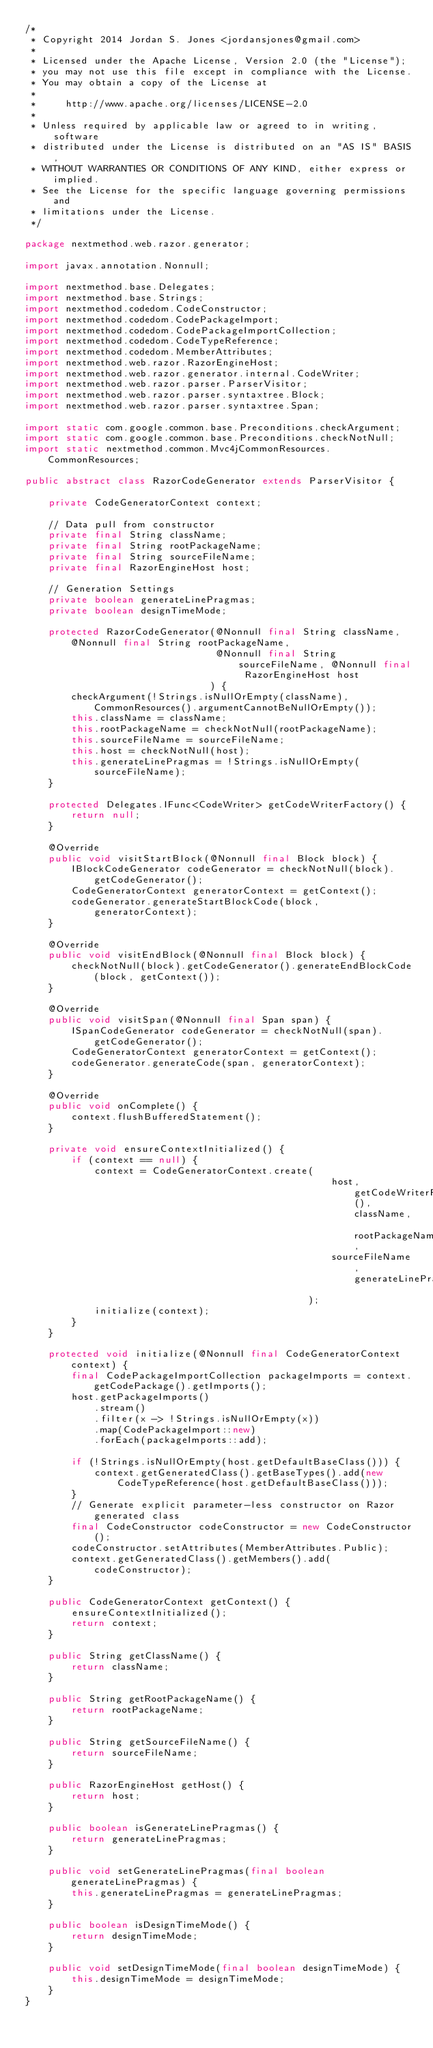<code> <loc_0><loc_0><loc_500><loc_500><_Java_>/*
 * Copyright 2014 Jordan S. Jones <jordansjones@gmail.com>
 *
 * Licensed under the Apache License, Version 2.0 (the "License");
 * you may not use this file except in compliance with the License.
 * You may obtain a copy of the License at
 *
 *     http://www.apache.org/licenses/LICENSE-2.0
 *
 * Unless required by applicable law or agreed to in writing, software
 * distributed under the License is distributed on an "AS IS" BASIS,
 * WITHOUT WARRANTIES OR CONDITIONS OF ANY KIND, either express or implied.
 * See the License for the specific language governing permissions and
 * limitations under the License.
 */

package nextmethod.web.razor.generator;

import javax.annotation.Nonnull;

import nextmethod.base.Delegates;
import nextmethod.base.Strings;
import nextmethod.codedom.CodeConstructor;
import nextmethod.codedom.CodePackageImport;
import nextmethod.codedom.CodePackageImportCollection;
import nextmethod.codedom.CodeTypeReference;
import nextmethod.codedom.MemberAttributes;
import nextmethod.web.razor.RazorEngineHost;
import nextmethod.web.razor.generator.internal.CodeWriter;
import nextmethod.web.razor.parser.ParserVisitor;
import nextmethod.web.razor.parser.syntaxtree.Block;
import nextmethod.web.razor.parser.syntaxtree.Span;

import static com.google.common.base.Preconditions.checkArgument;
import static com.google.common.base.Preconditions.checkNotNull;
import static nextmethod.common.Mvc4jCommonResources.CommonResources;

public abstract class RazorCodeGenerator extends ParserVisitor {

    private CodeGeneratorContext context;

    // Data pull from constructor
    private final String className;
    private final String rootPackageName;
    private final String sourceFileName;
    private final RazorEngineHost host;

    // Generation Settings
    private boolean generateLinePragmas;
    private boolean designTimeMode;

    protected RazorCodeGenerator(@Nonnull final String className, @Nonnull final String rootPackageName,
                                 @Nonnull final String sourceFileName, @Nonnull final RazorEngineHost host
                                ) {
        checkArgument(!Strings.isNullOrEmpty(className), CommonResources().argumentCannotBeNullOrEmpty());
        this.className = className;
        this.rootPackageName = checkNotNull(rootPackageName);
        this.sourceFileName = sourceFileName;
        this.host = checkNotNull(host);
        this.generateLinePragmas = !Strings.isNullOrEmpty(sourceFileName);
    }

    protected Delegates.IFunc<CodeWriter> getCodeWriterFactory() {
        return null;
    }

    @Override
    public void visitStartBlock(@Nonnull final Block block) {
        IBlockCodeGenerator codeGenerator = checkNotNull(block).getCodeGenerator();
        CodeGeneratorContext generatorContext = getContext();
        codeGenerator.generateStartBlockCode(block, generatorContext);
    }

    @Override
    public void visitEndBlock(@Nonnull final Block block) {
        checkNotNull(block).getCodeGenerator().generateEndBlockCode(block, getContext());
    }

    @Override
    public void visitSpan(@Nonnull final Span span) {
        ISpanCodeGenerator codeGenerator = checkNotNull(span).getCodeGenerator();
        CodeGeneratorContext generatorContext = getContext();
        codeGenerator.generateCode(span, generatorContext);
    }

    @Override
    public void onComplete() {
        context.flushBufferedStatement();
    }

    private void ensureContextInitialized() {
        if (context == null) {
            context = CodeGeneratorContext.create(
                                                     host, getCodeWriterFactory(), className, rootPackageName,
                                                     sourceFileName, generateLinePragmas
                                                 );
            initialize(context);
        }
    }

    protected void initialize(@Nonnull final CodeGeneratorContext context) {
        final CodePackageImportCollection packageImports = context.getCodePackage().getImports();
        host.getPackageImports()
            .stream()
            .filter(x -> !Strings.isNullOrEmpty(x))
            .map(CodePackageImport::new)
            .forEach(packageImports::add);

        if (!Strings.isNullOrEmpty(host.getDefaultBaseClass())) {
            context.getGeneratedClass().getBaseTypes().add(new CodeTypeReference(host.getDefaultBaseClass()));
        }
        // Generate explicit parameter-less constructor on Razor generated class
        final CodeConstructor codeConstructor = new CodeConstructor();
        codeConstructor.setAttributes(MemberAttributes.Public);
        context.getGeneratedClass().getMembers().add(codeConstructor);
    }

    public CodeGeneratorContext getContext() {
        ensureContextInitialized();
        return context;
    }

    public String getClassName() {
        return className;
    }

    public String getRootPackageName() {
        return rootPackageName;
    }

    public String getSourceFileName() {
        return sourceFileName;
    }

    public RazorEngineHost getHost() {
        return host;
    }

    public boolean isGenerateLinePragmas() {
        return generateLinePragmas;
    }

    public void setGenerateLinePragmas(final boolean generateLinePragmas) {
        this.generateLinePragmas = generateLinePragmas;
    }

    public boolean isDesignTimeMode() {
        return designTimeMode;
    }

    public void setDesignTimeMode(final boolean designTimeMode) {
        this.designTimeMode = designTimeMode;
    }
}
</code> 